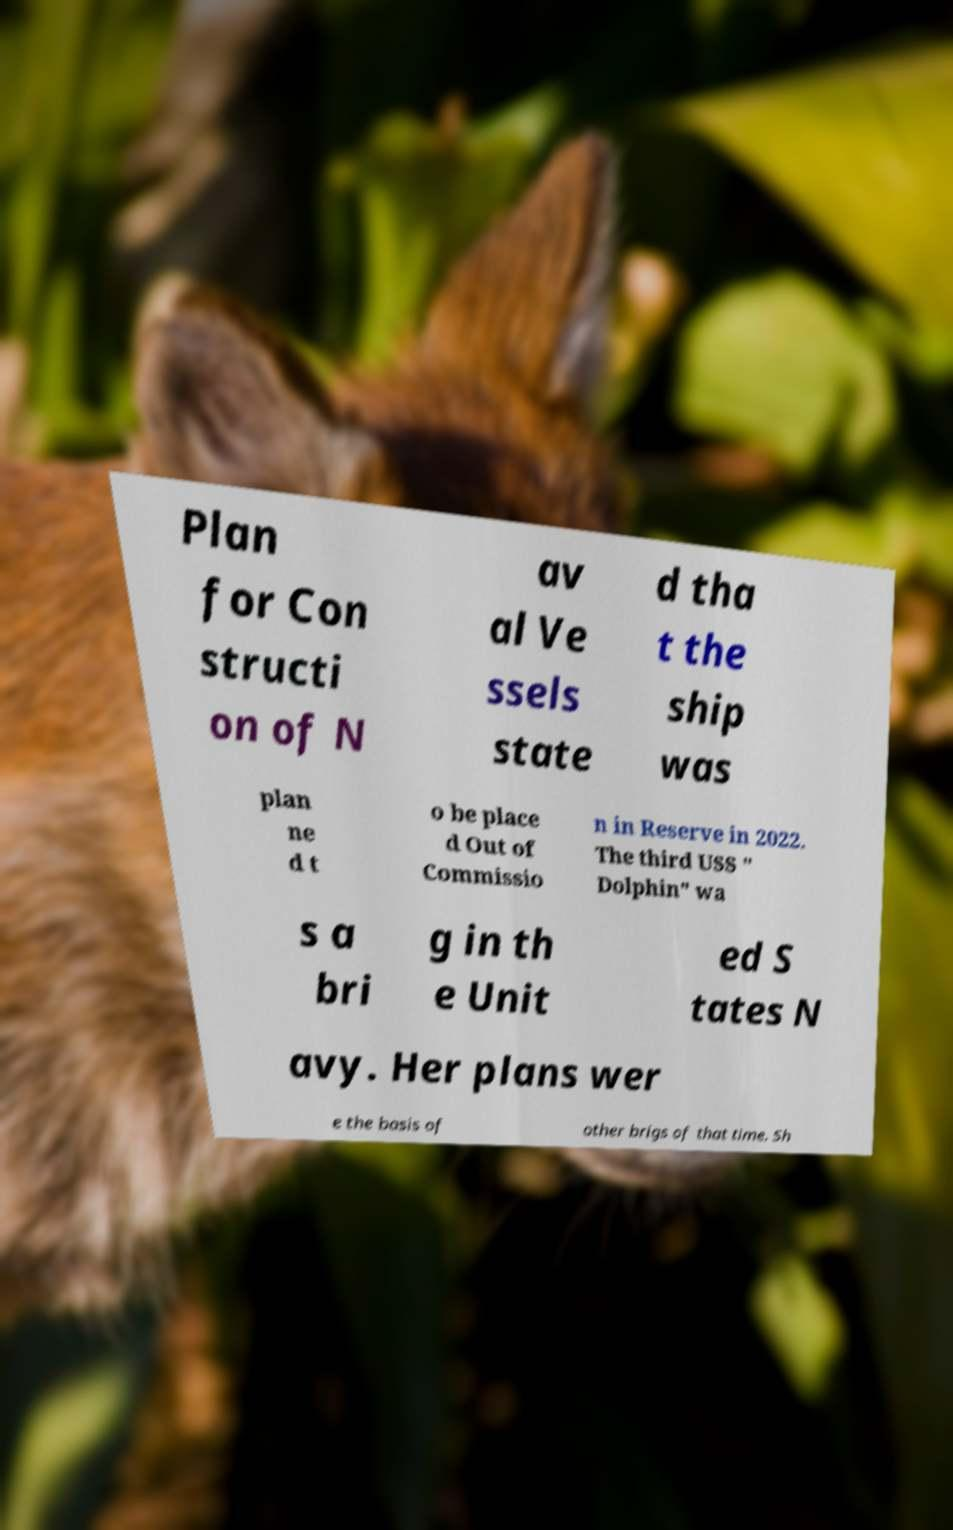There's text embedded in this image that I need extracted. Can you transcribe it verbatim? Plan for Con structi on of N av al Ve ssels state d tha t the ship was plan ne d t o be place d Out of Commissio n in Reserve in 2022. The third USS " Dolphin" wa s a bri g in th e Unit ed S tates N avy. Her plans wer e the basis of other brigs of that time. Sh 